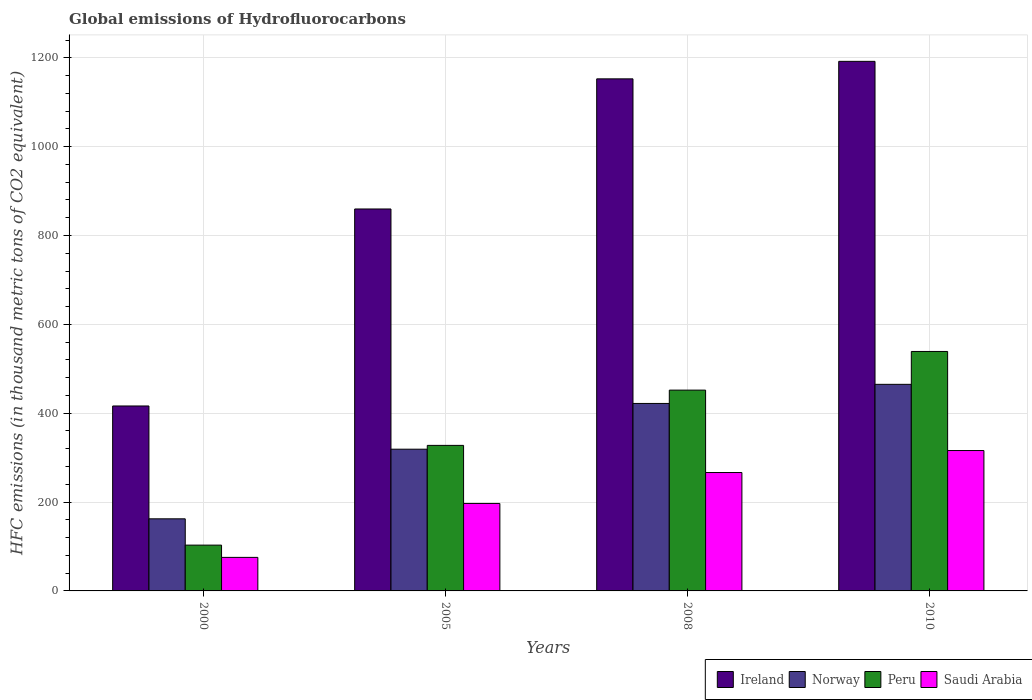How many different coloured bars are there?
Make the answer very short. 4. How many bars are there on the 2nd tick from the left?
Provide a succinct answer. 4. In how many cases, is the number of bars for a given year not equal to the number of legend labels?
Provide a succinct answer. 0. What is the global emissions of Hydrofluorocarbons in Peru in 2010?
Provide a short and direct response. 539. Across all years, what is the maximum global emissions of Hydrofluorocarbons in Peru?
Give a very brief answer. 539. Across all years, what is the minimum global emissions of Hydrofluorocarbons in Ireland?
Make the answer very short. 416.3. In which year was the global emissions of Hydrofluorocarbons in Norway minimum?
Make the answer very short. 2000. What is the total global emissions of Hydrofluorocarbons in Peru in the graph?
Provide a succinct answer. 1421.7. What is the difference between the global emissions of Hydrofluorocarbons in Norway in 2005 and that in 2010?
Your answer should be very brief. -146. What is the difference between the global emissions of Hydrofluorocarbons in Norway in 2000 and the global emissions of Hydrofluorocarbons in Saudi Arabia in 2010?
Ensure brevity in your answer.  -153.7. What is the average global emissions of Hydrofluorocarbons in Saudi Arabia per year?
Provide a short and direct response. 213.72. In the year 2005, what is the difference between the global emissions of Hydrofluorocarbons in Ireland and global emissions of Hydrofluorocarbons in Norway?
Provide a short and direct response. 540.7. In how many years, is the global emissions of Hydrofluorocarbons in Saudi Arabia greater than 1080 thousand metric tons?
Your response must be concise. 0. What is the ratio of the global emissions of Hydrofluorocarbons in Ireland in 2000 to that in 2010?
Offer a terse response. 0.35. Is the global emissions of Hydrofluorocarbons in Ireland in 2000 less than that in 2008?
Keep it short and to the point. Yes. Is the difference between the global emissions of Hydrofluorocarbons in Ireland in 2008 and 2010 greater than the difference between the global emissions of Hydrofluorocarbons in Norway in 2008 and 2010?
Offer a terse response. Yes. What is the difference between the highest and the second highest global emissions of Hydrofluorocarbons in Saudi Arabia?
Ensure brevity in your answer.  49.5. What is the difference between the highest and the lowest global emissions of Hydrofluorocarbons in Peru?
Provide a short and direct response. 435.9. Is the sum of the global emissions of Hydrofluorocarbons in Saudi Arabia in 2008 and 2010 greater than the maximum global emissions of Hydrofluorocarbons in Ireland across all years?
Ensure brevity in your answer.  No. Is it the case that in every year, the sum of the global emissions of Hydrofluorocarbons in Ireland and global emissions of Hydrofluorocarbons in Norway is greater than the sum of global emissions of Hydrofluorocarbons in Saudi Arabia and global emissions of Hydrofluorocarbons in Peru?
Provide a succinct answer. No. Is it the case that in every year, the sum of the global emissions of Hydrofluorocarbons in Peru and global emissions of Hydrofluorocarbons in Ireland is greater than the global emissions of Hydrofluorocarbons in Saudi Arabia?
Offer a terse response. Yes. Are all the bars in the graph horizontal?
Ensure brevity in your answer.  No. How many years are there in the graph?
Offer a terse response. 4. Are the values on the major ticks of Y-axis written in scientific E-notation?
Your answer should be very brief. No. How many legend labels are there?
Make the answer very short. 4. What is the title of the graph?
Offer a terse response. Global emissions of Hydrofluorocarbons. What is the label or title of the Y-axis?
Your answer should be compact. HFC emissions (in thousand metric tons of CO2 equivalent). What is the HFC emissions (in thousand metric tons of CO2 equivalent) of Ireland in 2000?
Ensure brevity in your answer.  416.3. What is the HFC emissions (in thousand metric tons of CO2 equivalent) of Norway in 2000?
Your response must be concise. 162.3. What is the HFC emissions (in thousand metric tons of CO2 equivalent) in Peru in 2000?
Your answer should be compact. 103.1. What is the HFC emissions (in thousand metric tons of CO2 equivalent) of Saudi Arabia in 2000?
Offer a terse response. 75.5. What is the HFC emissions (in thousand metric tons of CO2 equivalent) in Ireland in 2005?
Provide a succinct answer. 859.7. What is the HFC emissions (in thousand metric tons of CO2 equivalent) of Norway in 2005?
Offer a terse response. 319. What is the HFC emissions (in thousand metric tons of CO2 equivalent) of Peru in 2005?
Offer a very short reply. 327.6. What is the HFC emissions (in thousand metric tons of CO2 equivalent) of Saudi Arabia in 2005?
Make the answer very short. 196.9. What is the HFC emissions (in thousand metric tons of CO2 equivalent) in Ireland in 2008?
Keep it short and to the point. 1152.6. What is the HFC emissions (in thousand metric tons of CO2 equivalent) of Norway in 2008?
Make the answer very short. 422. What is the HFC emissions (in thousand metric tons of CO2 equivalent) in Peru in 2008?
Provide a succinct answer. 452. What is the HFC emissions (in thousand metric tons of CO2 equivalent) of Saudi Arabia in 2008?
Provide a short and direct response. 266.5. What is the HFC emissions (in thousand metric tons of CO2 equivalent) of Ireland in 2010?
Offer a very short reply. 1192. What is the HFC emissions (in thousand metric tons of CO2 equivalent) of Norway in 2010?
Offer a very short reply. 465. What is the HFC emissions (in thousand metric tons of CO2 equivalent) in Peru in 2010?
Ensure brevity in your answer.  539. What is the HFC emissions (in thousand metric tons of CO2 equivalent) of Saudi Arabia in 2010?
Your response must be concise. 316. Across all years, what is the maximum HFC emissions (in thousand metric tons of CO2 equivalent) of Ireland?
Provide a short and direct response. 1192. Across all years, what is the maximum HFC emissions (in thousand metric tons of CO2 equivalent) in Norway?
Ensure brevity in your answer.  465. Across all years, what is the maximum HFC emissions (in thousand metric tons of CO2 equivalent) of Peru?
Provide a succinct answer. 539. Across all years, what is the maximum HFC emissions (in thousand metric tons of CO2 equivalent) of Saudi Arabia?
Keep it short and to the point. 316. Across all years, what is the minimum HFC emissions (in thousand metric tons of CO2 equivalent) of Ireland?
Make the answer very short. 416.3. Across all years, what is the minimum HFC emissions (in thousand metric tons of CO2 equivalent) of Norway?
Keep it short and to the point. 162.3. Across all years, what is the minimum HFC emissions (in thousand metric tons of CO2 equivalent) in Peru?
Your answer should be compact. 103.1. Across all years, what is the minimum HFC emissions (in thousand metric tons of CO2 equivalent) of Saudi Arabia?
Provide a short and direct response. 75.5. What is the total HFC emissions (in thousand metric tons of CO2 equivalent) in Ireland in the graph?
Your answer should be very brief. 3620.6. What is the total HFC emissions (in thousand metric tons of CO2 equivalent) of Norway in the graph?
Make the answer very short. 1368.3. What is the total HFC emissions (in thousand metric tons of CO2 equivalent) in Peru in the graph?
Offer a very short reply. 1421.7. What is the total HFC emissions (in thousand metric tons of CO2 equivalent) of Saudi Arabia in the graph?
Your response must be concise. 854.9. What is the difference between the HFC emissions (in thousand metric tons of CO2 equivalent) of Ireland in 2000 and that in 2005?
Keep it short and to the point. -443.4. What is the difference between the HFC emissions (in thousand metric tons of CO2 equivalent) of Norway in 2000 and that in 2005?
Give a very brief answer. -156.7. What is the difference between the HFC emissions (in thousand metric tons of CO2 equivalent) of Peru in 2000 and that in 2005?
Give a very brief answer. -224.5. What is the difference between the HFC emissions (in thousand metric tons of CO2 equivalent) in Saudi Arabia in 2000 and that in 2005?
Your answer should be very brief. -121.4. What is the difference between the HFC emissions (in thousand metric tons of CO2 equivalent) of Ireland in 2000 and that in 2008?
Offer a terse response. -736.3. What is the difference between the HFC emissions (in thousand metric tons of CO2 equivalent) of Norway in 2000 and that in 2008?
Offer a very short reply. -259.7. What is the difference between the HFC emissions (in thousand metric tons of CO2 equivalent) of Peru in 2000 and that in 2008?
Give a very brief answer. -348.9. What is the difference between the HFC emissions (in thousand metric tons of CO2 equivalent) in Saudi Arabia in 2000 and that in 2008?
Offer a very short reply. -191. What is the difference between the HFC emissions (in thousand metric tons of CO2 equivalent) in Ireland in 2000 and that in 2010?
Offer a very short reply. -775.7. What is the difference between the HFC emissions (in thousand metric tons of CO2 equivalent) of Norway in 2000 and that in 2010?
Your response must be concise. -302.7. What is the difference between the HFC emissions (in thousand metric tons of CO2 equivalent) of Peru in 2000 and that in 2010?
Keep it short and to the point. -435.9. What is the difference between the HFC emissions (in thousand metric tons of CO2 equivalent) of Saudi Arabia in 2000 and that in 2010?
Offer a terse response. -240.5. What is the difference between the HFC emissions (in thousand metric tons of CO2 equivalent) in Ireland in 2005 and that in 2008?
Keep it short and to the point. -292.9. What is the difference between the HFC emissions (in thousand metric tons of CO2 equivalent) in Norway in 2005 and that in 2008?
Provide a short and direct response. -103. What is the difference between the HFC emissions (in thousand metric tons of CO2 equivalent) in Peru in 2005 and that in 2008?
Your response must be concise. -124.4. What is the difference between the HFC emissions (in thousand metric tons of CO2 equivalent) of Saudi Arabia in 2005 and that in 2008?
Offer a very short reply. -69.6. What is the difference between the HFC emissions (in thousand metric tons of CO2 equivalent) of Ireland in 2005 and that in 2010?
Give a very brief answer. -332.3. What is the difference between the HFC emissions (in thousand metric tons of CO2 equivalent) in Norway in 2005 and that in 2010?
Provide a short and direct response. -146. What is the difference between the HFC emissions (in thousand metric tons of CO2 equivalent) of Peru in 2005 and that in 2010?
Your answer should be very brief. -211.4. What is the difference between the HFC emissions (in thousand metric tons of CO2 equivalent) of Saudi Arabia in 2005 and that in 2010?
Offer a very short reply. -119.1. What is the difference between the HFC emissions (in thousand metric tons of CO2 equivalent) of Ireland in 2008 and that in 2010?
Ensure brevity in your answer.  -39.4. What is the difference between the HFC emissions (in thousand metric tons of CO2 equivalent) in Norway in 2008 and that in 2010?
Provide a succinct answer. -43. What is the difference between the HFC emissions (in thousand metric tons of CO2 equivalent) of Peru in 2008 and that in 2010?
Offer a terse response. -87. What is the difference between the HFC emissions (in thousand metric tons of CO2 equivalent) in Saudi Arabia in 2008 and that in 2010?
Offer a terse response. -49.5. What is the difference between the HFC emissions (in thousand metric tons of CO2 equivalent) of Ireland in 2000 and the HFC emissions (in thousand metric tons of CO2 equivalent) of Norway in 2005?
Offer a terse response. 97.3. What is the difference between the HFC emissions (in thousand metric tons of CO2 equivalent) of Ireland in 2000 and the HFC emissions (in thousand metric tons of CO2 equivalent) of Peru in 2005?
Your answer should be very brief. 88.7. What is the difference between the HFC emissions (in thousand metric tons of CO2 equivalent) in Ireland in 2000 and the HFC emissions (in thousand metric tons of CO2 equivalent) in Saudi Arabia in 2005?
Provide a succinct answer. 219.4. What is the difference between the HFC emissions (in thousand metric tons of CO2 equivalent) of Norway in 2000 and the HFC emissions (in thousand metric tons of CO2 equivalent) of Peru in 2005?
Your answer should be compact. -165.3. What is the difference between the HFC emissions (in thousand metric tons of CO2 equivalent) in Norway in 2000 and the HFC emissions (in thousand metric tons of CO2 equivalent) in Saudi Arabia in 2005?
Keep it short and to the point. -34.6. What is the difference between the HFC emissions (in thousand metric tons of CO2 equivalent) of Peru in 2000 and the HFC emissions (in thousand metric tons of CO2 equivalent) of Saudi Arabia in 2005?
Your answer should be compact. -93.8. What is the difference between the HFC emissions (in thousand metric tons of CO2 equivalent) in Ireland in 2000 and the HFC emissions (in thousand metric tons of CO2 equivalent) in Norway in 2008?
Your answer should be compact. -5.7. What is the difference between the HFC emissions (in thousand metric tons of CO2 equivalent) of Ireland in 2000 and the HFC emissions (in thousand metric tons of CO2 equivalent) of Peru in 2008?
Your answer should be compact. -35.7. What is the difference between the HFC emissions (in thousand metric tons of CO2 equivalent) in Ireland in 2000 and the HFC emissions (in thousand metric tons of CO2 equivalent) in Saudi Arabia in 2008?
Your answer should be very brief. 149.8. What is the difference between the HFC emissions (in thousand metric tons of CO2 equivalent) in Norway in 2000 and the HFC emissions (in thousand metric tons of CO2 equivalent) in Peru in 2008?
Offer a very short reply. -289.7. What is the difference between the HFC emissions (in thousand metric tons of CO2 equivalent) in Norway in 2000 and the HFC emissions (in thousand metric tons of CO2 equivalent) in Saudi Arabia in 2008?
Provide a short and direct response. -104.2. What is the difference between the HFC emissions (in thousand metric tons of CO2 equivalent) of Peru in 2000 and the HFC emissions (in thousand metric tons of CO2 equivalent) of Saudi Arabia in 2008?
Provide a short and direct response. -163.4. What is the difference between the HFC emissions (in thousand metric tons of CO2 equivalent) of Ireland in 2000 and the HFC emissions (in thousand metric tons of CO2 equivalent) of Norway in 2010?
Provide a succinct answer. -48.7. What is the difference between the HFC emissions (in thousand metric tons of CO2 equivalent) of Ireland in 2000 and the HFC emissions (in thousand metric tons of CO2 equivalent) of Peru in 2010?
Provide a succinct answer. -122.7. What is the difference between the HFC emissions (in thousand metric tons of CO2 equivalent) of Ireland in 2000 and the HFC emissions (in thousand metric tons of CO2 equivalent) of Saudi Arabia in 2010?
Give a very brief answer. 100.3. What is the difference between the HFC emissions (in thousand metric tons of CO2 equivalent) of Norway in 2000 and the HFC emissions (in thousand metric tons of CO2 equivalent) of Peru in 2010?
Provide a succinct answer. -376.7. What is the difference between the HFC emissions (in thousand metric tons of CO2 equivalent) in Norway in 2000 and the HFC emissions (in thousand metric tons of CO2 equivalent) in Saudi Arabia in 2010?
Your answer should be compact. -153.7. What is the difference between the HFC emissions (in thousand metric tons of CO2 equivalent) of Peru in 2000 and the HFC emissions (in thousand metric tons of CO2 equivalent) of Saudi Arabia in 2010?
Your response must be concise. -212.9. What is the difference between the HFC emissions (in thousand metric tons of CO2 equivalent) of Ireland in 2005 and the HFC emissions (in thousand metric tons of CO2 equivalent) of Norway in 2008?
Make the answer very short. 437.7. What is the difference between the HFC emissions (in thousand metric tons of CO2 equivalent) of Ireland in 2005 and the HFC emissions (in thousand metric tons of CO2 equivalent) of Peru in 2008?
Provide a short and direct response. 407.7. What is the difference between the HFC emissions (in thousand metric tons of CO2 equivalent) of Ireland in 2005 and the HFC emissions (in thousand metric tons of CO2 equivalent) of Saudi Arabia in 2008?
Your answer should be compact. 593.2. What is the difference between the HFC emissions (in thousand metric tons of CO2 equivalent) of Norway in 2005 and the HFC emissions (in thousand metric tons of CO2 equivalent) of Peru in 2008?
Your answer should be very brief. -133. What is the difference between the HFC emissions (in thousand metric tons of CO2 equivalent) in Norway in 2005 and the HFC emissions (in thousand metric tons of CO2 equivalent) in Saudi Arabia in 2008?
Give a very brief answer. 52.5. What is the difference between the HFC emissions (in thousand metric tons of CO2 equivalent) of Peru in 2005 and the HFC emissions (in thousand metric tons of CO2 equivalent) of Saudi Arabia in 2008?
Offer a very short reply. 61.1. What is the difference between the HFC emissions (in thousand metric tons of CO2 equivalent) of Ireland in 2005 and the HFC emissions (in thousand metric tons of CO2 equivalent) of Norway in 2010?
Offer a terse response. 394.7. What is the difference between the HFC emissions (in thousand metric tons of CO2 equivalent) of Ireland in 2005 and the HFC emissions (in thousand metric tons of CO2 equivalent) of Peru in 2010?
Your answer should be compact. 320.7. What is the difference between the HFC emissions (in thousand metric tons of CO2 equivalent) of Ireland in 2005 and the HFC emissions (in thousand metric tons of CO2 equivalent) of Saudi Arabia in 2010?
Provide a short and direct response. 543.7. What is the difference between the HFC emissions (in thousand metric tons of CO2 equivalent) of Norway in 2005 and the HFC emissions (in thousand metric tons of CO2 equivalent) of Peru in 2010?
Ensure brevity in your answer.  -220. What is the difference between the HFC emissions (in thousand metric tons of CO2 equivalent) in Norway in 2005 and the HFC emissions (in thousand metric tons of CO2 equivalent) in Saudi Arabia in 2010?
Make the answer very short. 3. What is the difference between the HFC emissions (in thousand metric tons of CO2 equivalent) in Ireland in 2008 and the HFC emissions (in thousand metric tons of CO2 equivalent) in Norway in 2010?
Offer a very short reply. 687.6. What is the difference between the HFC emissions (in thousand metric tons of CO2 equivalent) in Ireland in 2008 and the HFC emissions (in thousand metric tons of CO2 equivalent) in Peru in 2010?
Your answer should be compact. 613.6. What is the difference between the HFC emissions (in thousand metric tons of CO2 equivalent) in Ireland in 2008 and the HFC emissions (in thousand metric tons of CO2 equivalent) in Saudi Arabia in 2010?
Offer a terse response. 836.6. What is the difference between the HFC emissions (in thousand metric tons of CO2 equivalent) of Norway in 2008 and the HFC emissions (in thousand metric tons of CO2 equivalent) of Peru in 2010?
Provide a succinct answer. -117. What is the difference between the HFC emissions (in thousand metric tons of CO2 equivalent) of Norway in 2008 and the HFC emissions (in thousand metric tons of CO2 equivalent) of Saudi Arabia in 2010?
Ensure brevity in your answer.  106. What is the difference between the HFC emissions (in thousand metric tons of CO2 equivalent) in Peru in 2008 and the HFC emissions (in thousand metric tons of CO2 equivalent) in Saudi Arabia in 2010?
Offer a terse response. 136. What is the average HFC emissions (in thousand metric tons of CO2 equivalent) of Ireland per year?
Offer a terse response. 905.15. What is the average HFC emissions (in thousand metric tons of CO2 equivalent) of Norway per year?
Your answer should be very brief. 342.07. What is the average HFC emissions (in thousand metric tons of CO2 equivalent) of Peru per year?
Provide a succinct answer. 355.43. What is the average HFC emissions (in thousand metric tons of CO2 equivalent) in Saudi Arabia per year?
Provide a short and direct response. 213.72. In the year 2000, what is the difference between the HFC emissions (in thousand metric tons of CO2 equivalent) in Ireland and HFC emissions (in thousand metric tons of CO2 equivalent) in Norway?
Offer a very short reply. 254. In the year 2000, what is the difference between the HFC emissions (in thousand metric tons of CO2 equivalent) of Ireland and HFC emissions (in thousand metric tons of CO2 equivalent) of Peru?
Your answer should be very brief. 313.2. In the year 2000, what is the difference between the HFC emissions (in thousand metric tons of CO2 equivalent) of Ireland and HFC emissions (in thousand metric tons of CO2 equivalent) of Saudi Arabia?
Provide a succinct answer. 340.8. In the year 2000, what is the difference between the HFC emissions (in thousand metric tons of CO2 equivalent) of Norway and HFC emissions (in thousand metric tons of CO2 equivalent) of Peru?
Make the answer very short. 59.2. In the year 2000, what is the difference between the HFC emissions (in thousand metric tons of CO2 equivalent) of Norway and HFC emissions (in thousand metric tons of CO2 equivalent) of Saudi Arabia?
Your answer should be compact. 86.8. In the year 2000, what is the difference between the HFC emissions (in thousand metric tons of CO2 equivalent) of Peru and HFC emissions (in thousand metric tons of CO2 equivalent) of Saudi Arabia?
Give a very brief answer. 27.6. In the year 2005, what is the difference between the HFC emissions (in thousand metric tons of CO2 equivalent) of Ireland and HFC emissions (in thousand metric tons of CO2 equivalent) of Norway?
Your answer should be very brief. 540.7. In the year 2005, what is the difference between the HFC emissions (in thousand metric tons of CO2 equivalent) in Ireland and HFC emissions (in thousand metric tons of CO2 equivalent) in Peru?
Provide a short and direct response. 532.1. In the year 2005, what is the difference between the HFC emissions (in thousand metric tons of CO2 equivalent) in Ireland and HFC emissions (in thousand metric tons of CO2 equivalent) in Saudi Arabia?
Provide a succinct answer. 662.8. In the year 2005, what is the difference between the HFC emissions (in thousand metric tons of CO2 equivalent) of Norway and HFC emissions (in thousand metric tons of CO2 equivalent) of Peru?
Offer a terse response. -8.6. In the year 2005, what is the difference between the HFC emissions (in thousand metric tons of CO2 equivalent) of Norway and HFC emissions (in thousand metric tons of CO2 equivalent) of Saudi Arabia?
Give a very brief answer. 122.1. In the year 2005, what is the difference between the HFC emissions (in thousand metric tons of CO2 equivalent) of Peru and HFC emissions (in thousand metric tons of CO2 equivalent) of Saudi Arabia?
Give a very brief answer. 130.7. In the year 2008, what is the difference between the HFC emissions (in thousand metric tons of CO2 equivalent) in Ireland and HFC emissions (in thousand metric tons of CO2 equivalent) in Norway?
Provide a short and direct response. 730.6. In the year 2008, what is the difference between the HFC emissions (in thousand metric tons of CO2 equivalent) in Ireland and HFC emissions (in thousand metric tons of CO2 equivalent) in Peru?
Your answer should be compact. 700.6. In the year 2008, what is the difference between the HFC emissions (in thousand metric tons of CO2 equivalent) in Ireland and HFC emissions (in thousand metric tons of CO2 equivalent) in Saudi Arabia?
Give a very brief answer. 886.1. In the year 2008, what is the difference between the HFC emissions (in thousand metric tons of CO2 equivalent) in Norway and HFC emissions (in thousand metric tons of CO2 equivalent) in Saudi Arabia?
Your response must be concise. 155.5. In the year 2008, what is the difference between the HFC emissions (in thousand metric tons of CO2 equivalent) in Peru and HFC emissions (in thousand metric tons of CO2 equivalent) in Saudi Arabia?
Keep it short and to the point. 185.5. In the year 2010, what is the difference between the HFC emissions (in thousand metric tons of CO2 equivalent) in Ireland and HFC emissions (in thousand metric tons of CO2 equivalent) in Norway?
Keep it short and to the point. 727. In the year 2010, what is the difference between the HFC emissions (in thousand metric tons of CO2 equivalent) in Ireland and HFC emissions (in thousand metric tons of CO2 equivalent) in Peru?
Offer a terse response. 653. In the year 2010, what is the difference between the HFC emissions (in thousand metric tons of CO2 equivalent) of Ireland and HFC emissions (in thousand metric tons of CO2 equivalent) of Saudi Arabia?
Ensure brevity in your answer.  876. In the year 2010, what is the difference between the HFC emissions (in thousand metric tons of CO2 equivalent) of Norway and HFC emissions (in thousand metric tons of CO2 equivalent) of Peru?
Make the answer very short. -74. In the year 2010, what is the difference between the HFC emissions (in thousand metric tons of CO2 equivalent) of Norway and HFC emissions (in thousand metric tons of CO2 equivalent) of Saudi Arabia?
Provide a succinct answer. 149. In the year 2010, what is the difference between the HFC emissions (in thousand metric tons of CO2 equivalent) in Peru and HFC emissions (in thousand metric tons of CO2 equivalent) in Saudi Arabia?
Ensure brevity in your answer.  223. What is the ratio of the HFC emissions (in thousand metric tons of CO2 equivalent) in Ireland in 2000 to that in 2005?
Provide a short and direct response. 0.48. What is the ratio of the HFC emissions (in thousand metric tons of CO2 equivalent) in Norway in 2000 to that in 2005?
Make the answer very short. 0.51. What is the ratio of the HFC emissions (in thousand metric tons of CO2 equivalent) in Peru in 2000 to that in 2005?
Ensure brevity in your answer.  0.31. What is the ratio of the HFC emissions (in thousand metric tons of CO2 equivalent) in Saudi Arabia in 2000 to that in 2005?
Provide a succinct answer. 0.38. What is the ratio of the HFC emissions (in thousand metric tons of CO2 equivalent) in Ireland in 2000 to that in 2008?
Your response must be concise. 0.36. What is the ratio of the HFC emissions (in thousand metric tons of CO2 equivalent) in Norway in 2000 to that in 2008?
Ensure brevity in your answer.  0.38. What is the ratio of the HFC emissions (in thousand metric tons of CO2 equivalent) in Peru in 2000 to that in 2008?
Make the answer very short. 0.23. What is the ratio of the HFC emissions (in thousand metric tons of CO2 equivalent) in Saudi Arabia in 2000 to that in 2008?
Ensure brevity in your answer.  0.28. What is the ratio of the HFC emissions (in thousand metric tons of CO2 equivalent) of Ireland in 2000 to that in 2010?
Provide a succinct answer. 0.35. What is the ratio of the HFC emissions (in thousand metric tons of CO2 equivalent) of Norway in 2000 to that in 2010?
Give a very brief answer. 0.35. What is the ratio of the HFC emissions (in thousand metric tons of CO2 equivalent) in Peru in 2000 to that in 2010?
Provide a short and direct response. 0.19. What is the ratio of the HFC emissions (in thousand metric tons of CO2 equivalent) in Saudi Arabia in 2000 to that in 2010?
Give a very brief answer. 0.24. What is the ratio of the HFC emissions (in thousand metric tons of CO2 equivalent) of Ireland in 2005 to that in 2008?
Offer a terse response. 0.75. What is the ratio of the HFC emissions (in thousand metric tons of CO2 equivalent) in Norway in 2005 to that in 2008?
Ensure brevity in your answer.  0.76. What is the ratio of the HFC emissions (in thousand metric tons of CO2 equivalent) in Peru in 2005 to that in 2008?
Make the answer very short. 0.72. What is the ratio of the HFC emissions (in thousand metric tons of CO2 equivalent) in Saudi Arabia in 2005 to that in 2008?
Provide a short and direct response. 0.74. What is the ratio of the HFC emissions (in thousand metric tons of CO2 equivalent) of Ireland in 2005 to that in 2010?
Provide a short and direct response. 0.72. What is the ratio of the HFC emissions (in thousand metric tons of CO2 equivalent) in Norway in 2005 to that in 2010?
Keep it short and to the point. 0.69. What is the ratio of the HFC emissions (in thousand metric tons of CO2 equivalent) of Peru in 2005 to that in 2010?
Keep it short and to the point. 0.61. What is the ratio of the HFC emissions (in thousand metric tons of CO2 equivalent) of Saudi Arabia in 2005 to that in 2010?
Your answer should be compact. 0.62. What is the ratio of the HFC emissions (in thousand metric tons of CO2 equivalent) in Ireland in 2008 to that in 2010?
Offer a very short reply. 0.97. What is the ratio of the HFC emissions (in thousand metric tons of CO2 equivalent) in Norway in 2008 to that in 2010?
Provide a short and direct response. 0.91. What is the ratio of the HFC emissions (in thousand metric tons of CO2 equivalent) of Peru in 2008 to that in 2010?
Your answer should be very brief. 0.84. What is the ratio of the HFC emissions (in thousand metric tons of CO2 equivalent) in Saudi Arabia in 2008 to that in 2010?
Your response must be concise. 0.84. What is the difference between the highest and the second highest HFC emissions (in thousand metric tons of CO2 equivalent) in Ireland?
Your answer should be very brief. 39.4. What is the difference between the highest and the second highest HFC emissions (in thousand metric tons of CO2 equivalent) of Norway?
Offer a very short reply. 43. What is the difference between the highest and the second highest HFC emissions (in thousand metric tons of CO2 equivalent) in Saudi Arabia?
Offer a terse response. 49.5. What is the difference between the highest and the lowest HFC emissions (in thousand metric tons of CO2 equivalent) in Ireland?
Offer a very short reply. 775.7. What is the difference between the highest and the lowest HFC emissions (in thousand metric tons of CO2 equivalent) in Norway?
Provide a short and direct response. 302.7. What is the difference between the highest and the lowest HFC emissions (in thousand metric tons of CO2 equivalent) of Peru?
Ensure brevity in your answer.  435.9. What is the difference between the highest and the lowest HFC emissions (in thousand metric tons of CO2 equivalent) of Saudi Arabia?
Your response must be concise. 240.5. 